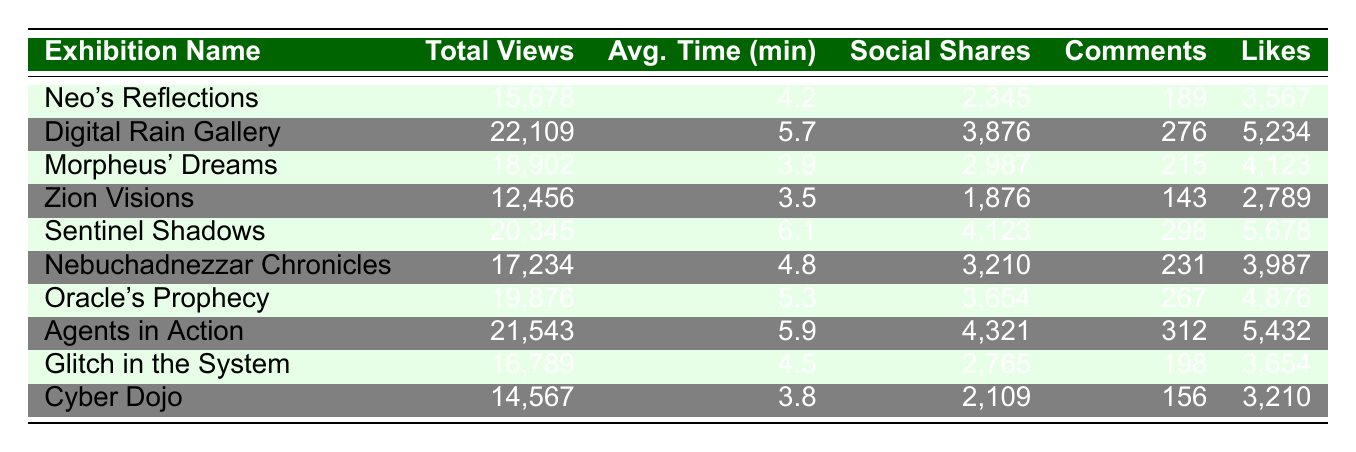What is the total number of views for "Digital Rain Gallery"? The total views for "Digital Rain Gallery" is listed directly in the table as 22,109.
Answer: 22,109 Which exhibition received the highest number of social shares? By inspecting the "Social Shares" column, the highest value is 4,321, which belongs to "Agents in Action."
Answer: Agents in Action What is the average time spent across all exhibitions? To calculate the average time spent, sum all the average times: (4.2 + 5.7 + 3.9 + 3.5 + 6.1 + 4.8 + 5.3 + 5.9 + 4.5 + 3.8) = 53.7. Then divide by the number of exhibitions (10): 53.7 / 10 = 5.37.
Answer: 5.37 Did "Zion Visions" get more likes than "Cyber Dojo"? "Zion Visions" received 2,789 likes while "Cyber Dojo" received 3,210 likes. Hence, Zion Visions did not get more likes than Cyber Dojo.
Answer: No Which exhibition had the lowest engagement in terms of average time spent and total views? "Zion Visions" had the lowest average time spent at 3.5 minutes and also had the lowest total views at 12,456. Therefore, it had the lowest engagement overall.
Answer: Zion Visions How many comments did the exhibition with the second-highest number of likes receive? The second-highest number of likes is 5,678 from "Sentinel Shadows," which received 298 comments according to the table.
Answer: 298 What is the difference in total views between "Neo's Reflections" and "Oracle's Prophecy"? "Neo's Reflections" has 15,678 total views while "Oracle's Prophecy" has 19,876 views. The difference is 19,876 - 15,678 = 4,198.
Answer: 4,198 Is the average time spent on "Morpheus' Dreams" greater than that of "Glitch in the System"? "Morpheus' Dreams" has an average time spent of 3.9 minutes, while "Glitch in the System" has 4.5 minutes. Thus, Morpheus' Dreams does not have greater average time spent.
Answer: No 